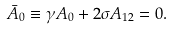<formula> <loc_0><loc_0><loc_500><loc_500>\bar { A } _ { 0 } \equiv \gamma A _ { 0 } + 2 \sigma A _ { 1 2 } = 0 .</formula> 